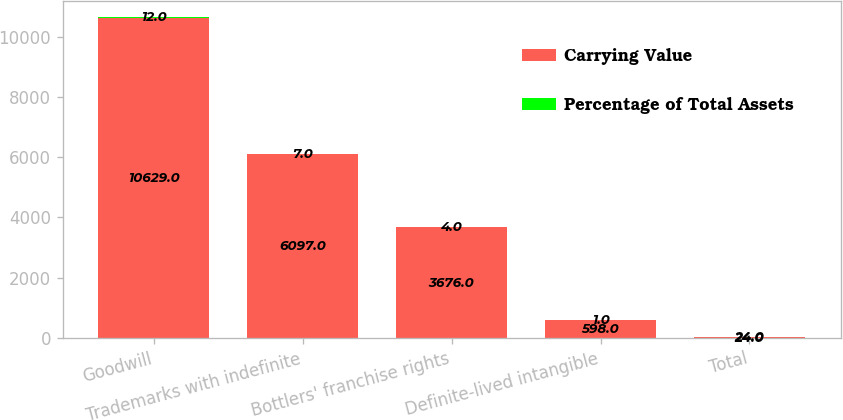Convert chart to OTSL. <chart><loc_0><loc_0><loc_500><loc_500><stacked_bar_chart><ecel><fcel>Goodwill<fcel>Trademarks with indefinite<fcel>Bottlers' franchise rights<fcel>Definite-lived intangible<fcel>Total<nl><fcel>Carrying Value<fcel>10629<fcel>6097<fcel>3676<fcel>598<fcel>24<nl><fcel>Percentage of Total Assets<fcel>12<fcel>7<fcel>4<fcel>1<fcel>24<nl></chart> 